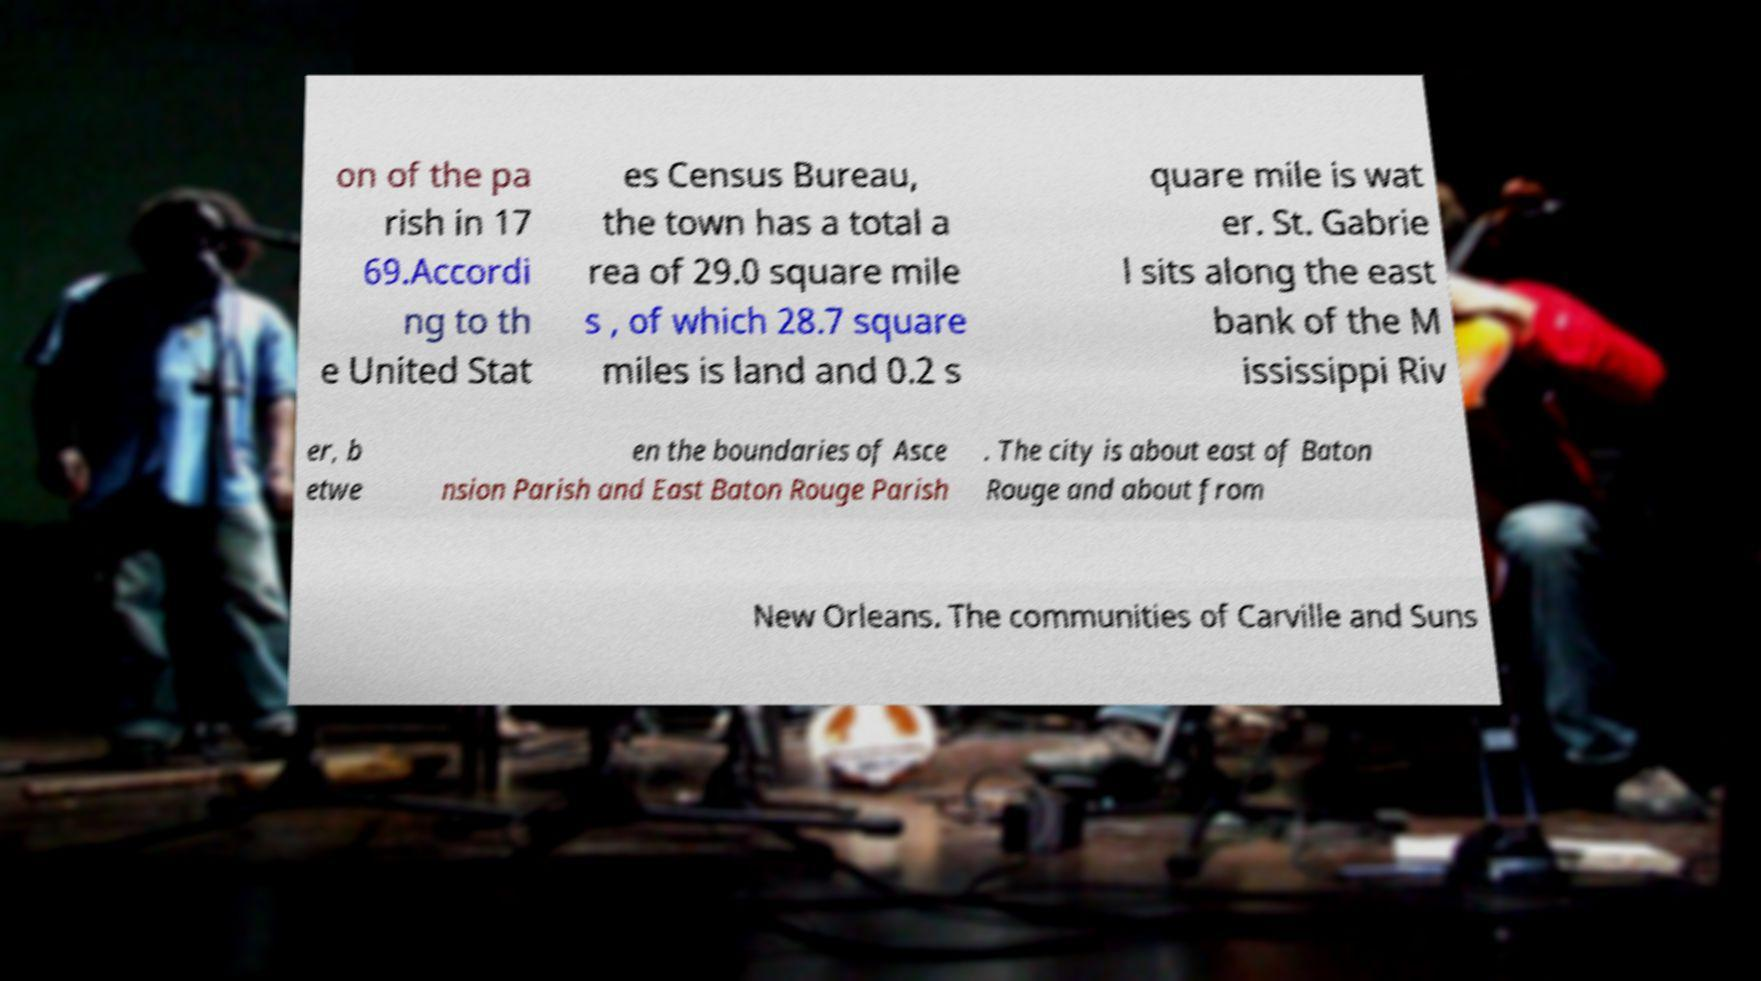There's text embedded in this image that I need extracted. Can you transcribe it verbatim? on of the pa rish in 17 69.Accordi ng to th e United Stat es Census Bureau, the town has a total a rea of 29.0 square mile s , of which 28.7 square miles is land and 0.2 s quare mile is wat er. St. Gabrie l sits along the east bank of the M ississippi Riv er, b etwe en the boundaries of Asce nsion Parish and East Baton Rouge Parish . The city is about east of Baton Rouge and about from New Orleans. The communities of Carville and Suns 